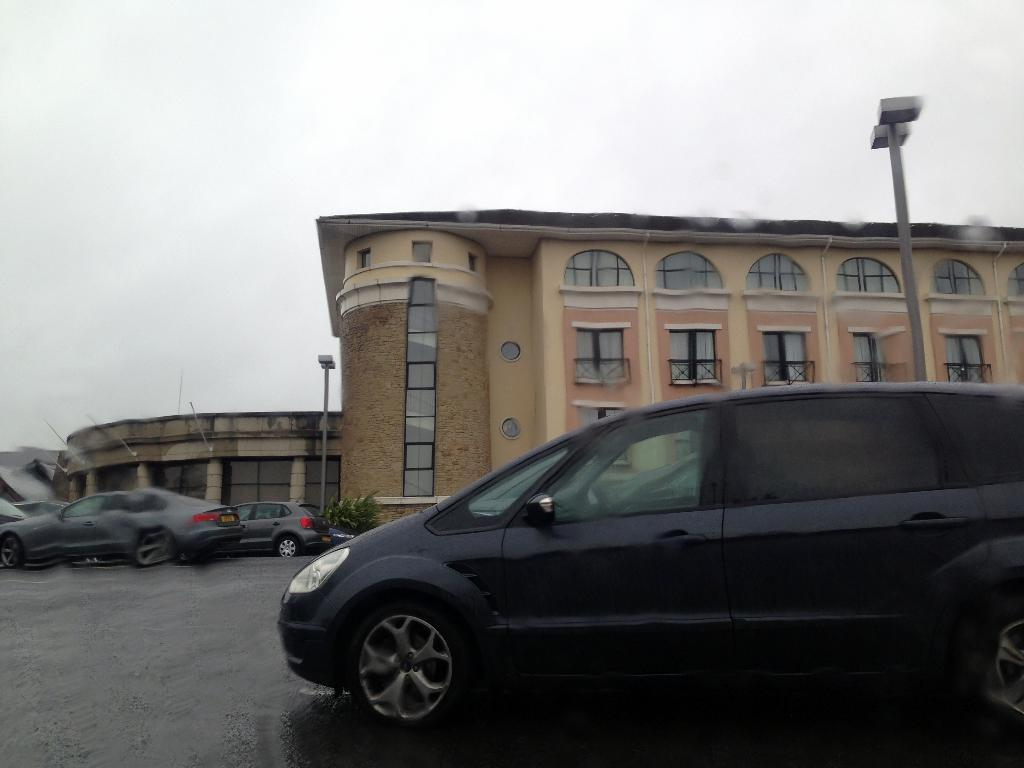What type of structures can be seen in the image? There are buildings in the image. What else is present in the image besides buildings? There are vehicles and street lights in the image. What can be seen in the background of the image? The sky is visible in the background of the image. Can you tell me how many lines are drawn on the zoo in the image? There is no zoo present in the image, and therefore no lines can be drawn on it. 